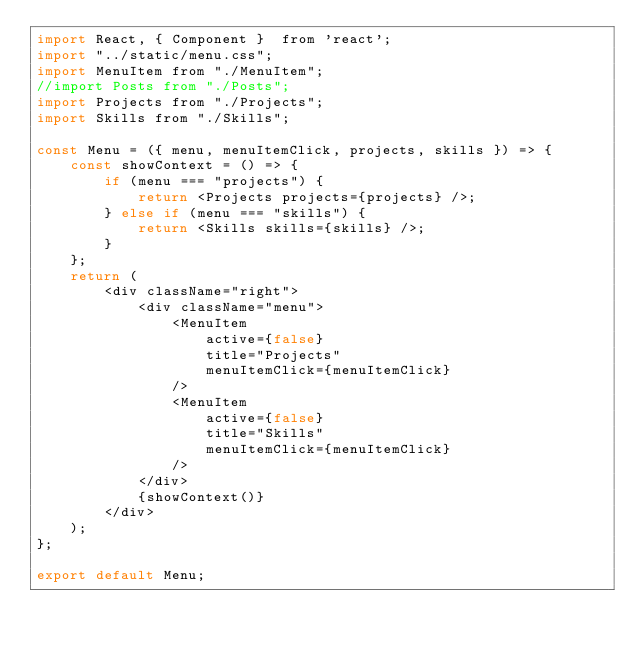Convert code to text. <code><loc_0><loc_0><loc_500><loc_500><_JavaScript_>import React, { Component }  from 'react';
import "../static/menu.css";
import MenuItem from "./MenuItem";
//import Posts from "./Posts";
import Projects from "./Projects";
import Skills from "./Skills";

const Menu = ({ menu, menuItemClick, projects, skills }) => {
	const showContext = () => {
		if (menu === "projects") {
			return <Projects projects={projects} />;
		} else if (menu === "skills") {
			return <Skills skills={skills} />;
		}
	};
	return (
		<div className="right">
			<div className="menu">
				<MenuItem
					active={false}
					title="Projects"
					menuItemClick={menuItemClick}
				/>
				<MenuItem
					active={false}
					title="Skills"
					menuItemClick={menuItemClick}
				/>
			</div>
			{showContext()}
		</div>
	);
};

export default Menu;
</code> 